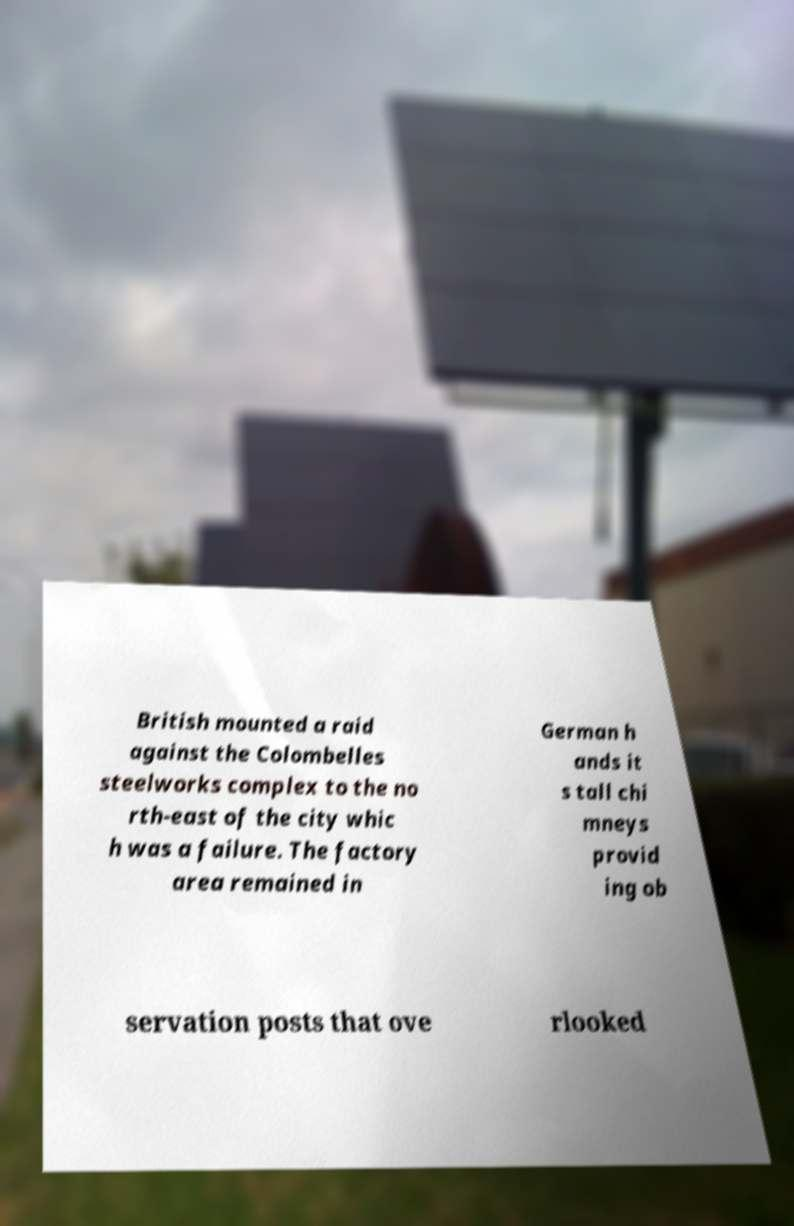Could you extract and type out the text from this image? British mounted a raid against the Colombelles steelworks complex to the no rth-east of the city whic h was a failure. The factory area remained in German h ands it s tall chi mneys provid ing ob servation posts that ove rlooked 